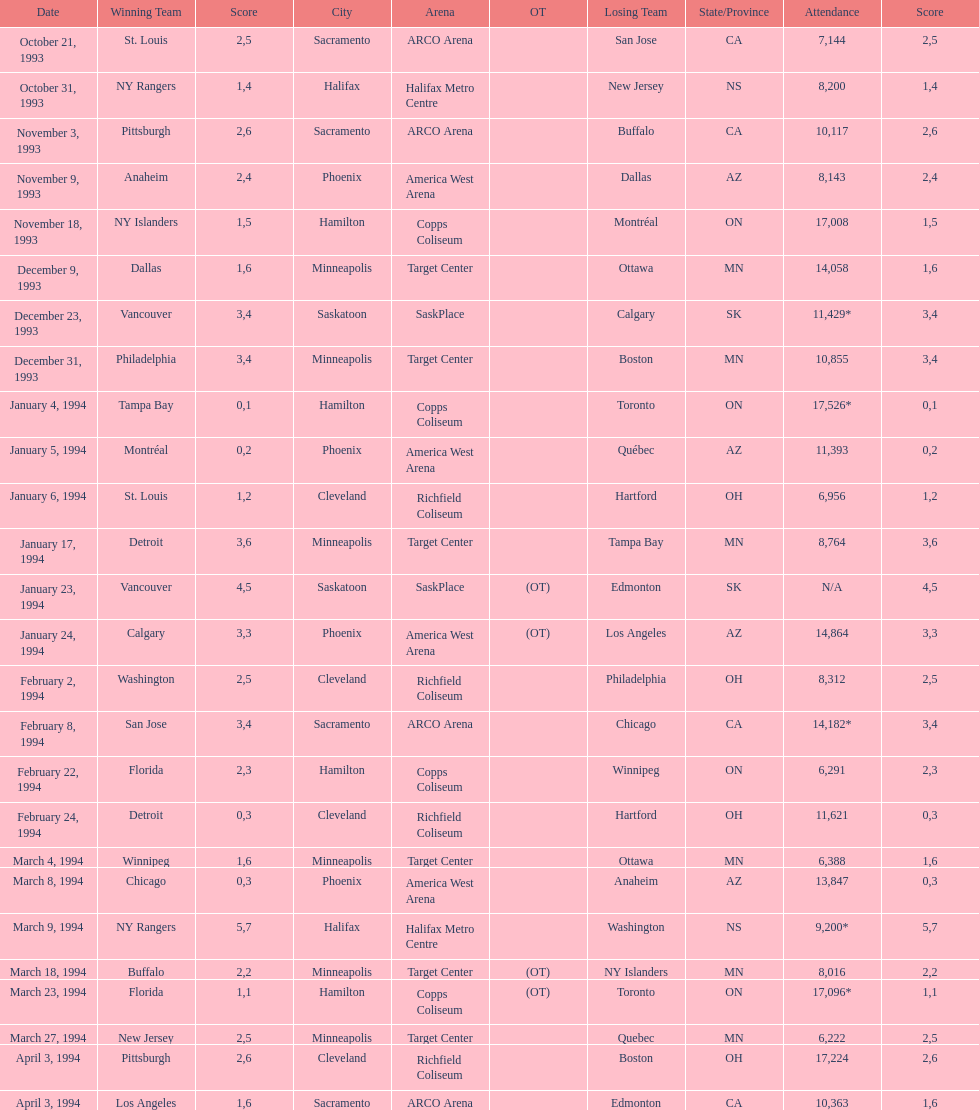Did dallas or ottawa win the december 9, 1993 game? Dallas. 